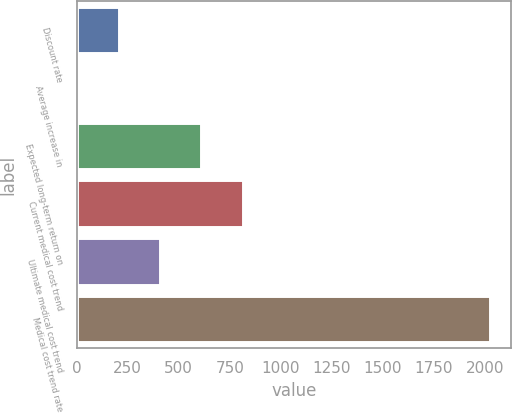<chart> <loc_0><loc_0><loc_500><loc_500><bar_chart><fcel>Discount rate<fcel>Average increase in<fcel>Expected long-term return on<fcel>Current medical cost trend<fcel>Ultimate medical cost trend<fcel>Medical cost trend rate<nl><fcel>205.75<fcel>3.5<fcel>610.25<fcel>812.5<fcel>408<fcel>2026<nl></chart> 